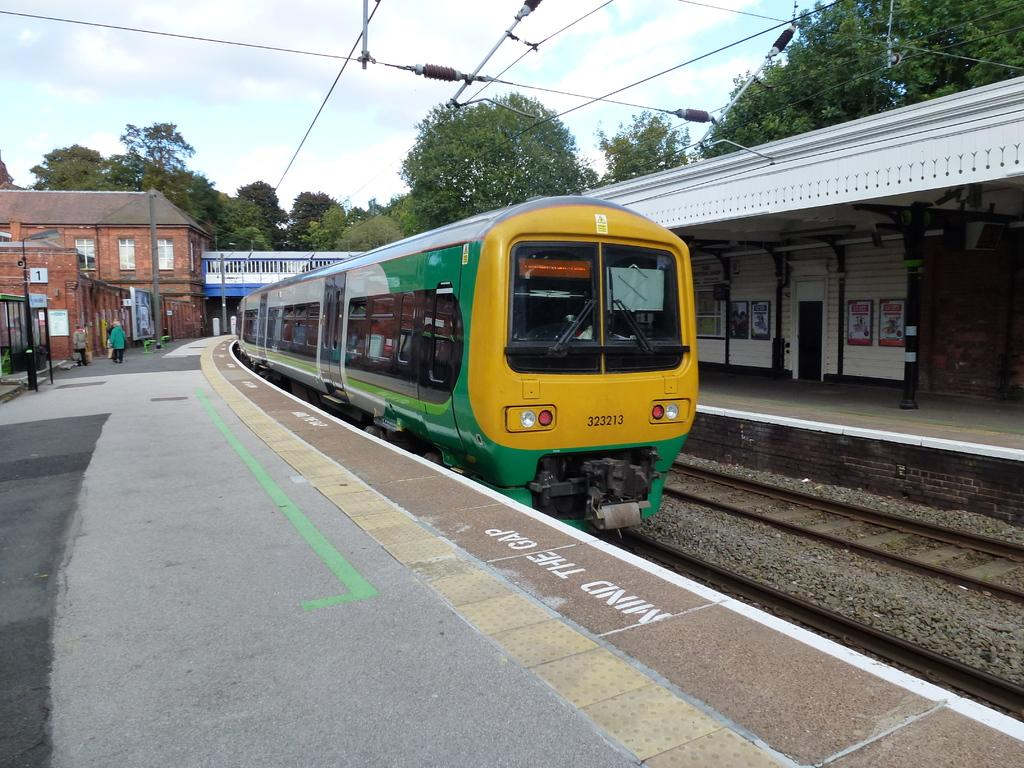<image>
Create a compact narrative representing the image presented. A train is about to pass by the words mind the gap 